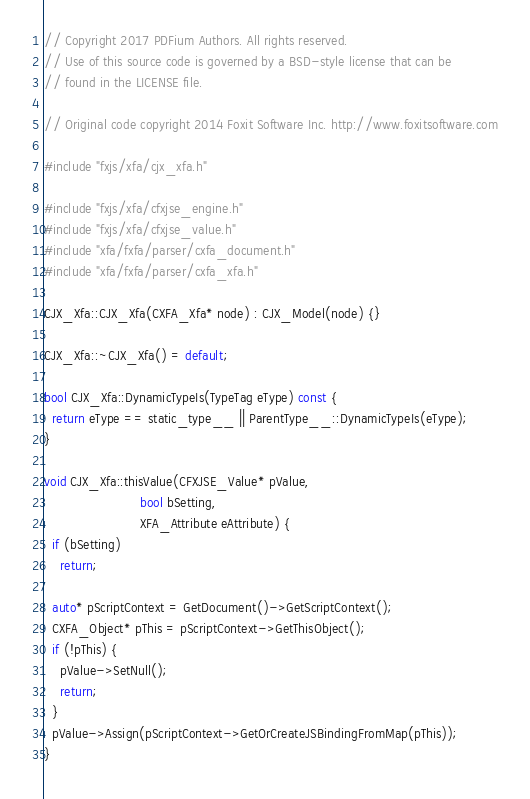<code> <loc_0><loc_0><loc_500><loc_500><_C++_>// Copyright 2017 PDFium Authors. All rights reserved.
// Use of this source code is governed by a BSD-style license that can be
// found in the LICENSE file.

// Original code copyright 2014 Foxit Software Inc. http://www.foxitsoftware.com

#include "fxjs/xfa/cjx_xfa.h"

#include "fxjs/xfa/cfxjse_engine.h"
#include "fxjs/xfa/cfxjse_value.h"
#include "xfa/fxfa/parser/cxfa_document.h"
#include "xfa/fxfa/parser/cxfa_xfa.h"

CJX_Xfa::CJX_Xfa(CXFA_Xfa* node) : CJX_Model(node) {}

CJX_Xfa::~CJX_Xfa() = default;

bool CJX_Xfa::DynamicTypeIs(TypeTag eType) const {
  return eType == static_type__ || ParentType__::DynamicTypeIs(eType);
}

void CJX_Xfa::thisValue(CFXJSE_Value* pValue,
                        bool bSetting,
                        XFA_Attribute eAttribute) {
  if (bSetting)
    return;

  auto* pScriptContext = GetDocument()->GetScriptContext();
  CXFA_Object* pThis = pScriptContext->GetThisObject();
  if (!pThis) {
    pValue->SetNull();
    return;
  }
  pValue->Assign(pScriptContext->GetOrCreateJSBindingFromMap(pThis));
}
</code> 